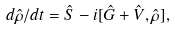Convert formula to latex. <formula><loc_0><loc_0><loc_500><loc_500>d \hat { \rho } / d t = { \hat { S } } - i [ \hat { G } + \hat { V } , \hat { \rho } ] ,</formula> 